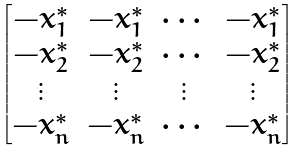Convert formula to latex. <formula><loc_0><loc_0><loc_500><loc_500>\begin{bmatrix} - x _ { 1 } ^ { * } & - x _ { 1 } ^ { * } & \cdots & - x _ { 1 } ^ { * } \\ - x _ { 2 } ^ { * } & - x _ { 2 } ^ { * } & \cdots & - x _ { 2 } ^ { * } \\ \vdots & \vdots & \vdots & \vdots \\ - x _ { n } ^ { * } & - x _ { n } ^ { * } & \cdots & - x _ { n } ^ { * } \end{bmatrix}</formula> 